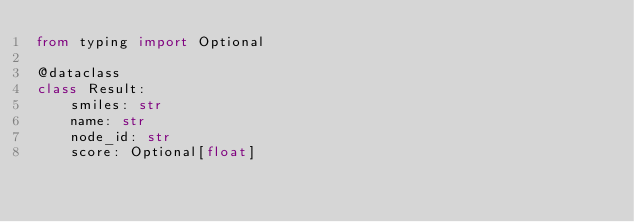<code> <loc_0><loc_0><loc_500><loc_500><_Python_>from typing import Optional

@dataclass
class Result:
    smiles: str
    name: str
    node_id: str
    score: Optional[float]</code> 